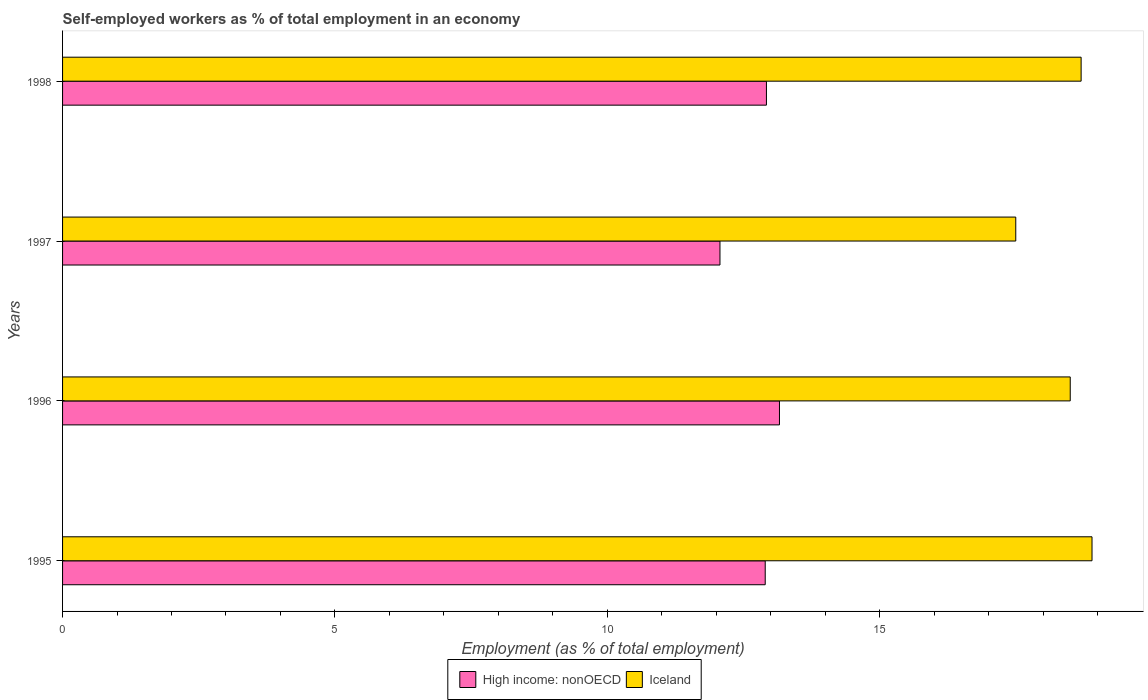How many groups of bars are there?
Your answer should be very brief. 4. Are the number of bars per tick equal to the number of legend labels?
Provide a succinct answer. Yes. How many bars are there on the 2nd tick from the bottom?
Your response must be concise. 2. In how many cases, is the number of bars for a given year not equal to the number of legend labels?
Your answer should be compact. 0. What is the percentage of self-employed workers in High income: nonOECD in 1996?
Keep it short and to the point. 13.16. Across all years, what is the maximum percentage of self-employed workers in Iceland?
Provide a succinct answer. 18.9. Across all years, what is the minimum percentage of self-employed workers in Iceland?
Ensure brevity in your answer.  17.5. In which year was the percentage of self-employed workers in Iceland maximum?
Provide a short and direct response. 1995. What is the total percentage of self-employed workers in Iceland in the graph?
Offer a very short reply. 73.6. What is the difference between the percentage of self-employed workers in High income: nonOECD in 1995 and that in 1997?
Offer a very short reply. 0.83. What is the difference between the percentage of self-employed workers in Iceland in 1995 and the percentage of self-employed workers in High income: nonOECD in 1997?
Provide a short and direct response. 6.83. What is the average percentage of self-employed workers in High income: nonOECD per year?
Your answer should be compact. 12.76. In the year 1996, what is the difference between the percentage of self-employed workers in High income: nonOECD and percentage of self-employed workers in Iceland?
Provide a succinct answer. -5.34. What is the ratio of the percentage of self-employed workers in Iceland in 1997 to that in 1998?
Your answer should be very brief. 0.94. Is the percentage of self-employed workers in High income: nonOECD in 1995 less than that in 1997?
Provide a short and direct response. No. What is the difference between the highest and the second highest percentage of self-employed workers in Iceland?
Offer a terse response. 0.2. What is the difference between the highest and the lowest percentage of self-employed workers in High income: nonOECD?
Keep it short and to the point. 1.09. In how many years, is the percentage of self-employed workers in High income: nonOECD greater than the average percentage of self-employed workers in High income: nonOECD taken over all years?
Keep it short and to the point. 3. Is the sum of the percentage of self-employed workers in Iceland in 1995 and 1996 greater than the maximum percentage of self-employed workers in High income: nonOECD across all years?
Ensure brevity in your answer.  Yes. What does the 2nd bar from the bottom in 1997 represents?
Offer a terse response. Iceland. How many years are there in the graph?
Offer a terse response. 4. Are the values on the major ticks of X-axis written in scientific E-notation?
Your answer should be compact. No. Does the graph contain any zero values?
Provide a short and direct response. No. Does the graph contain grids?
Make the answer very short. No. What is the title of the graph?
Provide a succinct answer. Self-employed workers as % of total employment in an economy. What is the label or title of the X-axis?
Give a very brief answer. Employment (as % of total employment). What is the Employment (as % of total employment) of High income: nonOECD in 1995?
Offer a terse response. 12.9. What is the Employment (as % of total employment) in Iceland in 1995?
Keep it short and to the point. 18.9. What is the Employment (as % of total employment) in High income: nonOECD in 1996?
Make the answer very short. 13.16. What is the Employment (as % of total employment) of High income: nonOECD in 1997?
Provide a short and direct response. 12.07. What is the Employment (as % of total employment) of Iceland in 1997?
Give a very brief answer. 17.5. What is the Employment (as % of total employment) of High income: nonOECD in 1998?
Offer a very short reply. 12.92. What is the Employment (as % of total employment) of Iceland in 1998?
Your response must be concise. 18.7. Across all years, what is the maximum Employment (as % of total employment) of High income: nonOECD?
Make the answer very short. 13.16. Across all years, what is the maximum Employment (as % of total employment) of Iceland?
Provide a succinct answer. 18.9. Across all years, what is the minimum Employment (as % of total employment) of High income: nonOECD?
Your response must be concise. 12.07. What is the total Employment (as % of total employment) of High income: nonOECD in the graph?
Keep it short and to the point. 51.05. What is the total Employment (as % of total employment) in Iceland in the graph?
Your answer should be compact. 73.6. What is the difference between the Employment (as % of total employment) of High income: nonOECD in 1995 and that in 1996?
Make the answer very short. -0.26. What is the difference between the Employment (as % of total employment) in Iceland in 1995 and that in 1996?
Offer a very short reply. 0.4. What is the difference between the Employment (as % of total employment) of High income: nonOECD in 1995 and that in 1997?
Ensure brevity in your answer.  0.83. What is the difference between the Employment (as % of total employment) in High income: nonOECD in 1995 and that in 1998?
Offer a very short reply. -0.02. What is the difference between the Employment (as % of total employment) of Iceland in 1995 and that in 1998?
Your answer should be compact. 0.2. What is the difference between the Employment (as % of total employment) of High income: nonOECD in 1996 and that in 1997?
Offer a terse response. 1.09. What is the difference between the Employment (as % of total employment) in High income: nonOECD in 1996 and that in 1998?
Give a very brief answer. 0.24. What is the difference between the Employment (as % of total employment) in High income: nonOECD in 1997 and that in 1998?
Your response must be concise. -0.85. What is the difference between the Employment (as % of total employment) of High income: nonOECD in 1995 and the Employment (as % of total employment) of Iceland in 1996?
Provide a succinct answer. -5.6. What is the difference between the Employment (as % of total employment) in High income: nonOECD in 1995 and the Employment (as % of total employment) in Iceland in 1997?
Give a very brief answer. -4.6. What is the difference between the Employment (as % of total employment) of High income: nonOECD in 1995 and the Employment (as % of total employment) of Iceland in 1998?
Make the answer very short. -5.8. What is the difference between the Employment (as % of total employment) of High income: nonOECD in 1996 and the Employment (as % of total employment) of Iceland in 1997?
Make the answer very short. -4.34. What is the difference between the Employment (as % of total employment) of High income: nonOECD in 1996 and the Employment (as % of total employment) of Iceland in 1998?
Give a very brief answer. -5.54. What is the difference between the Employment (as % of total employment) in High income: nonOECD in 1997 and the Employment (as % of total employment) in Iceland in 1998?
Give a very brief answer. -6.63. What is the average Employment (as % of total employment) of High income: nonOECD per year?
Make the answer very short. 12.76. What is the average Employment (as % of total employment) in Iceland per year?
Offer a terse response. 18.4. In the year 1995, what is the difference between the Employment (as % of total employment) of High income: nonOECD and Employment (as % of total employment) of Iceland?
Offer a very short reply. -6. In the year 1996, what is the difference between the Employment (as % of total employment) of High income: nonOECD and Employment (as % of total employment) of Iceland?
Offer a very short reply. -5.34. In the year 1997, what is the difference between the Employment (as % of total employment) in High income: nonOECD and Employment (as % of total employment) in Iceland?
Offer a very short reply. -5.43. In the year 1998, what is the difference between the Employment (as % of total employment) of High income: nonOECD and Employment (as % of total employment) of Iceland?
Offer a very short reply. -5.78. What is the ratio of the Employment (as % of total employment) in High income: nonOECD in 1995 to that in 1996?
Make the answer very short. 0.98. What is the ratio of the Employment (as % of total employment) of Iceland in 1995 to that in 1996?
Offer a terse response. 1.02. What is the ratio of the Employment (as % of total employment) of High income: nonOECD in 1995 to that in 1997?
Your response must be concise. 1.07. What is the ratio of the Employment (as % of total employment) in Iceland in 1995 to that in 1997?
Provide a short and direct response. 1.08. What is the ratio of the Employment (as % of total employment) of Iceland in 1995 to that in 1998?
Offer a terse response. 1.01. What is the ratio of the Employment (as % of total employment) of High income: nonOECD in 1996 to that in 1997?
Give a very brief answer. 1.09. What is the ratio of the Employment (as % of total employment) of Iceland in 1996 to that in 1997?
Offer a very short reply. 1.06. What is the ratio of the Employment (as % of total employment) in High income: nonOECD in 1996 to that in 1998?
Give a very brief answer. 1.02. What is the ratio of the Employment (as % of total employment) of Iceland in 1996 to that in 1998?
Provide a short and direct response. 0.99. What is the ratio of the Employment (as % of total employment) of High income: nonOECD in 1997 to that in 1998?
Your answer should be compact. 0.93. What is the ratio of the Employment (as % of total employment) of Iceland in 1997 to that in 1998?
Your answer should be very brief. 0.94. What is the difference between the highest and the second highest Employment (as % of total employment) in High income: nonOECD?
Your response must be concise. 0.24. What is the difference between the highest and the lowest Employment (as % of total employment) in High income: nonOECD?
Provide a short and direct response. 1.09. What is the difference between the highest and the lowest Employment (as % of total employment) of Iceland?
Your response must be concise. 1.4. 